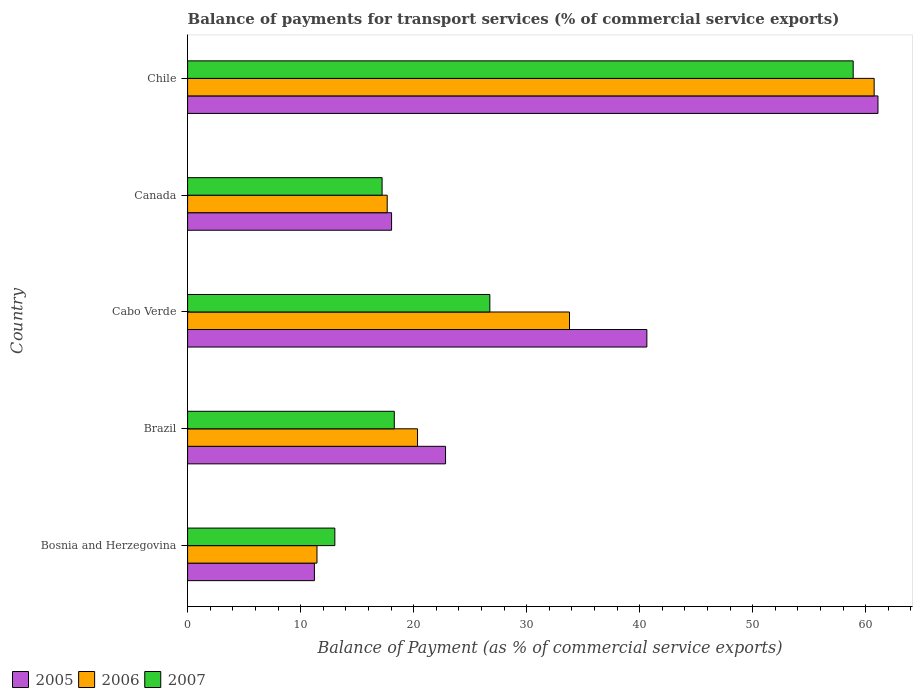Are the number of bars per tick equal to the number of legend labels?
Offer a terse response. Yes. How many bars are there on the 2nd tick from the top?
Provide a succinct answer. 3. How many bars are there on the 4th tick from the bottom?
Keep it short and to the point. 3. What is the label of the 3rd group of bars from the top?
Make the answer very short. Cabo Verde. What is the balance of payments for transport services in 2005 in Cabo Verde?
Make the answer very short. 40.64. Across all countries, what is the maximum balance of payments for transport services in 2005?
Your response must be concise. 61.09. Across all countries, what is the minimum balance of payments for transport services in 2005?
Keep it short and to the point. 11.22. In which country was the balance of payments for transport services in 2006 minimum?
Give a very brief answer. Bosnia and Herzegovina. What is the total balance of payments for transport services in 2005 in the graph?
Provide a short and direct response. 153.83. What is the difference between the balance of payments for transport services in 2007 in Bosnia and Herzegovina and that in Cabo Verde?
Provide a short and direct response. -13.72. What is the difference between the balance of payments for transport services in 2006 in Brazil and the balance of payments for transport services in 2007 in Chile?
Ensure brevity in your answer.  -38.55. What is the average balance of payments for transport services in 2006 per country?
Provide a succinct answer. 28.8. What is the difference between the balance of payments for transport services in 2006 and balance of payments for transport services in 2007 in Cabo Verde?
Offer a very short reply. 7.05. In how many countries, is the balance of payments for transport services in 2005 greater than 26 %?
Provide a succinct answer. 2. What is the ratio of the balance of payments for transport services in 2005 in Bosnia and Herzegovina to that in Chile?
Your answer should be very brief. 0.18. Is the balance of payments for transport services in 2005 in Canada less than that in Chile?
Provide a succinct answer. Yes. What is the difference between the highest and the second highest balance of payments for transport services in 2006?
Offer a very short reply. 26.96. What is the difference between the highest and the lowest balance of payments for transport services in 2005?
Your answer should be compact. 49.87. In how many countries, is the balance of payments for transport services in 2006 greater than the average balance of payments for transport services in 2006 taken over all countries?
Offer a terse response. 2. Is the sum of the balance of payments for transport services in 2006 in Bosnia and Herzegovina and Cabo Verde greater than the maximum balance of payments for transport services in 2005 across all countries?
Make the answer very short. No. What does the 2nd bar from the top in Cabo Verde represents?
Give a very brief answer. 2006. What does the 2nd bar from the bottom in Chile represents?
Make the answer very short. 2006. Is it the case that in every country, the sum of the balance of payments for transport services in 2005 and balance of payments for transport services in 2006 is greater than the balance of payments for transport services in 2007?
Offer a very short reply. Yes. How many bars are there?
Give a very brief answer. 15. How many countries are there in the graph?
Provide a succinct answer. 5. Are the values on the major ticks of X-axis written in scientific E-notation?
Your response must be concise. No. Does the graph contain any zero values?
Offer a very short reply. No. How many legend labels are there?
Offer a very short reply. 3. What is the title of the graph?
Offer a terse response. Balance of payments for transport services (% of commercial service exports). Does "1997" appear as one of the legend labels in the graph?
Ensure brevity in your answer.  No. What is the label or title of the X-axis?
Your answer should be very brief. Balance of Payment (as % of commercial service exports). What is the label or title of the Y-axis?
Your answer should be very brief. Country. What is the Balance of Payment (as % of commercial service exports) in 2005 in Bosnia and Herzegovina?
Your answer should be compact. 11.22. What is the Balance of Payment (as % of commercial service exports) in 2006 in Bosnia and Herzegovina?
Your response must be concise. 11.45. What is the Balance of Payment (as % of commercial service exports) in 2007 in Bosnia and Herzegovina?
Ensure brevity in your answer.  13.03. What is the Balance of Payment (as % of commercial service exports) of 2005 in Brazil?
Offer a terse response. 22.83. What is the Balance of Payment (as % of commercial service exports) of 2006 in Brazil?
Offer a very short reply. 20.35. What is the Balance of Payment (as % of commercial service exports) in 2007 in Brazil?
Your answer should be very brief. 18.29. What is the Balance of Payment (as % of commercial service exports) of 2005 in Cabo Verde?
Keep it short and to the point. 40.64. What is the Balance of Payment (as % of commercial service exports) in 2006 in Cabo Verde?
Your answer should be compact. 33.79. What is the Balance of Payment (as % of commercial service exports) in 2007 in Cabo Verde?
Your answer should be very brief. 26.75. What is the Balance of Payment (as % of commercial service exports) of 2005 in Canada?
Keep it short and to the point. 18.05. What is the Balance of Payment (as % of commercial service exports) in 2006 in Canada?
Your answer should be compact. 17.66. What is the Balance of Payment (as % of commercial service exports) of 2007 in Canada?
Give a very brief answer. 17.21. What is the Balance of Payment (as % of commercial service exports) in 2005 in Chile?
Your answer should be very brief. 61.09. What is the Balance of Payment (as % of commercial service exports) in 2006 in Chile?
Your response must be concise. 60.75. What is the Balance of Payment (as % of commercial service exports) in 2007 in Chile?
Make the answer very short. 58.9. Across all countries, what is the maximum Balance of Payment (as % of commercial service exports) in 2005?
Provide a short and direct response. 61.09. Across all countries, what is the maximum Balance of Payment (as % of commercial service exports) in 2006?
Provide a succinct answer. 60.75. Across all countries, what is the maximum Balance of Payment (as % of commercial service exports) of 2007?
Provide a short and direct response. 58.9. Across all countries, what is the minimum Balance of Payment (as % of commercial service exports) in 2005?
Provide a succinct answer. 11.22. Across all countries, what is the minimum Balance of Payment (as % of commercial service exports) in 2006?
Provide a succinct answer. 11.45. Across all countries, what is the minimum Balance of Payment (as % of commercial service exports) in 2007?
Provide a succinct answer. 13.03. What is the total Balance of Payment (as % of commercial service exports) of 2005 in the graph?
Keep it short and to the point. 153.83. What is the total Balance of Payment (as % of commercial service exports) of 2006 in the graph?
Provide a short and direct response. 144. What is the total Balance of Payment (as % of commercial service exports) of 2007 in the graph?
Make the answer very short. 134.17. What is the difference between the Balance of Payment (as % of commercial service exports) in 2005 in Bosnia and Herzegovina and that in Brazil?
Ensure brevity in your answer.  -11.6. What is the difference between the Balance of Payment (as % of commercial service exports) in 2006 in Bosnia and Herzegovina and that in Brazil?
Offer a terse response. -8.9. What is the difference between the Balance of Payment (as % of commercial service exports) of 2007 in Bosnia and Herzegovina and that in Brazil?
Your answer should be very brief. -5.26. What is the difference between the Balance of Payment (as % of commercial service exports) in 2005 in Bosnia and Herzegovina and that in Cabo Verde?
Your response must be concise. -29.42. What is the difference between the Balance of Payment (as % of commercial service exports) in 2006 in Bosnia and Herzegovina and that in Cabo Verde?
Keep it short and to the point. -22.35. What is the difference between the Balance of Payment (as % of commercial service exports) in 2007 in Bosnia and Herzegovina and that in Cabo Verde?
Give a very brief answer. -13.72. What is the difference between the Balance of Payment (as % of commercial service exports) of 2005 in Bosnia and Herzegovina and that in Canada?
Offer a very short reply. -6.83. What is the difference between the Balance of Payment (as % of commercial service exports) in 2006 in Bosnia and Herzegovina and that in Canada?
Keep it short and to the point. -6.21. What is the difference between the Balance of Payment (as % of commercial service exports) of 2007 in Bosnia and Herzegovina and that in Canada?
Offer a very short reply. -4.18. What is the difference between the Balance of Payment (as % of commercial service exports) in 2005 in Bosnia and Herzegovina and that in Chile?
Make the answer very short. -49.87. What is the difference between the Balance of Payment (as % of commercial service exports) of 2006 in Bosnia and Herzegovina and that in Chile?
Keep it short and to the point. -49.3. What is the difference between the Balance of Payment (as % of commercial service exports) in 2007 in Bosnia and Herzegovina and that in Chile?
Your answer should be very brief. -45.87. What is the difference between the Balance of Payment (as % of commercial service exports) of 2005 in Brazil and that in Cabo Verde?
Your response must be concise. -17.81. What is the difference between the Balance of Payment (as % of commercial service exports) in 2006 in Brazil and that in Cabo Verde?
Keep it short and to the point. -13.45. What is the difference between the Balance of Payment (as % of commercial service exports) of 2007 in Brazil and that in Cabo Verde?
Ensure brevity in your answer.  -8.45. What is the difference between the Balance of Payment (as % of commercial service exports) of 2005 in Brazil and that in Canada?
Offer a very short reply. 4.78. What is the difference between the Balance of Payment (as % of commercial service exports) of 2006 in Brazil and that in Canada?
Your answer should be compact. 2.68. What is the difference between the Balance of Payment (as % of commercial service exports) of 2007 in Brazil and that in Canada?
Your answer should be very brief. 1.08. What is the difference between the Balance of Payment (as % of commercial service exports) in 2005 in Brazil and that in Chile?
Your response must be concise. -38.26. What is the difference between the Balance of Payment (as % of commercial service exports) of 2006 in Brazil and that in Chile?
Provide a short and direct response. -40.4. What is the difference between the Balance of Payment (as % of commercial service exports) in 2007 in Brazil and that in Chile?
Ensure brevity in your answer.  -40.61. What is the difference between the Balance of Payment (as % of commercial service exports) of 2005 in Cabo Verde and that in Canada?
Your answer should be very brief. 22.59. What is the difference between the Balance of Payment (as % of commercial service exports) of 2006 in Cabo Verde and that in Canada?
Give a very brief answer. 16.13. What is the difference between the Balance of Payment (as % of commercial service exports) in 2007 in Cabo Verde and that in Canada?
Offer a terse response. 9.53. What is the difference between the Balance of Payment (as % of commercial service exports) in 2005 in Cabo Verde and that in Chile?
Provide a succinct answer. -20.45. What is the difference between the Balance of Payment (as % of commercial service exports) of 2006 in Cabo Verde and that in Chile?
Offer a very short reply. -26.96. What is the difference between the Balance of Payment (as % of commercial service exports) in 2007 in Cabo Verde and that in Chile?
Your answer should be very brief. -32.15. What is the difference between the Balance of Payment (as % of commercial service exports) in 2005 in Canada and that in Chile?
Offer a very short reply. -43.04. What is the difference between the Balance of Payment (as % of commercial service exports) of 2006 in Canada and that in Chile?
Make the answer very short. -43.09. What is the difference between the Balance of Payment (as % of commercial service exports) of 2007 in Canada and that in Chile?
Provide a short and direct response. -41.69. What is the difference between the Balance of Payment (as % of commercial service exports) in 2005 in Bosnia and Herzegovina and the Balance of Payment (as % of commercial service exports) in 2006 in Brazil?
Give a very brief answer. -9.13. What is the difference between the Balance of Payment (as % of commercial service exports) of 2005 in Bosnia and Herzegovina and the Balance of Payment (as % of commercial service exports) of 2007 in Brazil?
Keep it short and to the point. -7.07. What is the difference between the Balance of Payment (as % of commercial service exports) of 2006 in Bosnia and Herzegovina and the Balance of Payment (as % of commercial service exports) of 2007 in Brazil?
Offer a very short reply. -6.84. What is the difference between the Balance of Payment (as % of commercial service exports) in 2005 in Bosnia and Herzegovina and the Balance of Payment (as % of commercial service exports) in 2006 in Cabo Verde?
Provide a succinct answer. -22.57. What is the difference between the Balance of Payment (as % of commercial service exports) of 2005 in Bosnia and Herzegovina and the Balance of Payment (as % of commercial service exports) of 2007 in Cabo Verde?
Keep it short and to the point. -15.52. What is the difference between the Balance of Payment (as % of commercial service exports) in 2006 in Bosnia and Herzegovina and the Balance of Payment (as % of commercial service exports) in 2007 in Cabo Verde?
Your response must be concise. -15.3. What is the difference between the Balance of Payment (as % of commercial service exports) of 2005 in Bosnia and Herzegovina and the Balance of Payment (as % of commercial service exports) of 2006 in Canada?
Offer a terse response. -6.44. What is the difference between the Balance of Payment (as % of commercial service exports) of 2005 in Bosnia and Herzegovina and the Balance of Payment (as % of commercial service exports) of 2007 in Canada?
Make the answer very short. -5.99. What is the difference between the Balance of Payment (as % of commercial service exports) of 2006 in Bosnia and Herzegovina and the Balance of Payment (as % of commercial service exports) of 2007 in Canada?
Your answer should be compact. -5.76. What is the difference between the Balance of Payment (as % of commercial service exports) in 2005 in Bosnia and Herzegovina and the Balance of Payment (as % of commercial service exports) in 2006 in Chile?
Provide a short and direct response. -49.53. What is the difference between the Balance of Payment (as % of commercial service exports) in 2005 in Bosnia and Herzegovina and the Balance of Payment (as % of commercial service exports) in 2007 in Chile?
Offer a terse response. -47.68. What is the difference between the Balance of Payment (as % of commercial service exports) of 2006 in Bosnia and Herzegovina and the Balance of Payment (as % of commercial service exports) of 2007 in Chile?
Make the answer very short. -47.45. What is the difference between the Balance of Payment (as % of commercial service exports) of 2005 in Brazil and the Balance of Payment (as % of commercial service exports) of 2006 in Cabo Verde?
Offer a terse response. -10.97. What is the difference between the Balance of Payment (as % of commercial service exports) of 2005 in Brazil and the Balance of Payment (as % of commercial service exports) of 2007 in Cabo Verde?
Provide a short and direct response. -3.92. What is the difference between the Balance of Payment (as % of commercial service exports) in 2006 in Brazil and the Balance of Payment (as % of commercial service exports) in 2007 in Cabo Verde?
Provide a succinct answer. -6.4. What is the difference between the Balance of Payment (as % of commercial service exports) in 2005 in Brazil and the Balance of Payment (as % of commercial service exports) in 2006 in Canada?
Your answer should be compact. 5.16. What is the difference between the Balance of Payment (as % of commercial service exports) of 2005 in Brazil and the Balance of Payment (as % of commercial service exports) of 2007 in Canada?
Keep it short and to the point. 5.62. What is the difference between the Balance of Payment (as % of commercial service exports) of 2006 in Brazil and the Balance of Payment (as % of commercial service exports) of 2007 in Canada?
Your response must be concise. 3.14. What is the difference between the Balance of Payment (as % of commercial service exports) of 2005 in Brazil and the Balance of Payment (as % of commercial service exports) of 2006 in Chile?
Give a very brief answer. -37.93. What is the difference between the Balance of Payment (as % of commercial service exports) in 2005 in Brazil and the Balance of Payment (as % of commercial service exports) in 2007 in Chile?
Provide a succinct answer. -36.07. What is the difference between the Balance of Payment (as % of commercial service exports) in 2006 in Brazil and the Balance of Payment (as % of commercial service exports) in 2007 in Chile?
Give a very brief answer. -38.55. What is the difference between the Balance of Payment (as % of commercial service exports) in 2005 in Cabo Verde and the Balance of Payment (as % of commercial service exports) in 2006 in Canada?
Offer a very short reply. 22.98. What is the difference between the Balance of Payment (as % of commercial service exports) of 2005 in Cabo Verde and the Balance of Payment (as % of commercial service exports) of 2007 in Canada?
Offer a terse response. 23.43. What is the difference between the Balance of Payment (as % of commercial service exports) in 2006 in Cabo Verde and the Balance of Payment (as % of commercial service exports) in 2007 in Canada?
Provide a succinct answer. 16.58. What is the difference between the Balance of Payment (as % of commercial service exports) in 2005 in Cabo Verde and the Balance of Payment (as % of commercial service exports) in 2006 in Chile?
Keep it short and to the point. -20.11. What is the difference between the Balance of Payment (as % of commercial service exports) in 2005 in Cabo Verde and the Balance of Payment (as % of commercial service exports) in 2007 in Chile?
Ensure brevity in your answer.  -18.26. What is the difference between the Balance of Payment (as % of commercial service exports) of 2006 in Cabo Verde and the Balance of Payment (as % of commercial service exports) of 2007 in Chile?
Provide a short and direct response. -25.1. What is the difference between the Balance of Payment (as % of commercial service exports) in 2005 in Canada and the Balance of Payment (as % of commercial service exports) in 2006 in Chile?
Your answer should be compact. -42.7. What is the difference between the Balance of Payment (as % of commercial service exports) of 2005 in Canada and the Balance of Payment (as % of commercial service exports) of 2007 in Chile?
Your answer should be compact. -40.85. What is the difference between the Balance of Payment (as % of commercial service exports) of 2006 in Canada and the Balance of Payment (as % of commercial service exports) of 2007 in Chile?
Give a very brief answer. -41.23. What is the average Balance of Payment (as % of commercial service exports) in 2005 per country?
Your answer should be very brief. 30.77. What is the average Balance of Payment (as % of commercial service exports) of 2006 per country?
Keep it short and to the point. 28.8. What is the average Balance of Payment (as % of commercial service exports) in 2007 per country?
Keep it short and to the point. 26.83. What is the difference between the Balance of Payment (as % of commercial service exports) in 2005 and Balance of Payment (as % of commercial service exports) in 2006 in Bosnia and Herzegovina?
Your response must be concise. -0.23. What is the difference between the Balance of Payment (as % of commercial service exports) of 2005 and Balance of Payment (as % of commercial service exports) of 2007 in Bosnia and Herzegovina?
Your answer should be very brief. -1.81. What is the difference between the Balance of Payment (as % of commercial service exports) in 2006 and Balance of Payment (as % of commercial service exports) in 2007 in Bosnia and Herzegovina?
Ensure brevity in your answer.  -1.58. What is the difference between the Balance of Payment (as % of commercial service exports) of 2005 and Balance of Payment (as % of commercial service exports) of 2006 in Brazil?
Keep it short and to the point. 2.48. What is the difference between the Balance of Payment (as % of commercial service exports) in 2005 and Balance of Payment (as % of commercial service exports) in 2007 in Brazil?
Make the answer very short. 4.54. What is the difference between the Balance of Payment (as % of commercial service exports) of 2006 and Balance of Payment (as % of commercial service exports) of 2007 in Brazil?
Your answer should be very brief. 2.06. What is the difference between the Balance of Payment (as % of commercial service exports) of 2005 and Balance of Payment (as % of commercial service exports) of 2006 in Cabo Verde?
Your answer should be very brief. 6.85. What is the difference between the Balance of Payment (as % of commercial service exports) of 2005 and Balance of Payment (as % of commercial service exports) of 2007 in Cabo Verde?
Give a very brief answer. 13.89. What is the difference between the Balance of Payment (as % of commercial service exports) in 2006 and Balance of Payment (as % of commercial service exports) in 2007 in Cabo Verde?
Offer a very short reply. 7.05. What is the difference between the Balance of Payment (as % of commercial service exports) of 2005 and Balance of Payment (as % of commercial service exports) of 2006 in Canada?
Your response must be concise. 0.39. What is the difference between the Balance of Payment (as % of commercial service exports) of 2005 and Balance of Payment (as % of commercial service exports) of 2007 in Canada?
Make the answer very short. 0.84. What is the difference between the Balance of Payment (as % of commercial service exports) of 2006 and Balance of Payment (as % of commercial service exports) of 2007 in Canada?
Your response must be concise. 0.45. What is the difference between the Balance of Payment (as % of commercial service exports) in 2005 and Balance of Payment (as % of commercial service exports) in 2006 in Chile?
Offer a very short reply. 0.34. What is the difference between the Balance of Payment (as % of commercial service exports) in 2005 and Balance of Payment (as % of commercial service exports) in 2007 in Chile?
Give a very brief answer. 2.19. What is the difference between the Balance of Payment (as % of commercial service exports) in 2006 and Balance of Payment (as % of commercial service exports) in 2007 in Chile?
Your response must be concise. 1.85. What is the ratio of the Balance of Payment (as % of commercial service exports) in 2005 in Bosnia and Herzegovina to that in Brazil?
Keep it short and to the point. 0.49. What is the ratio of the Balance of Payment (as % of commercial service exports) in 2006 in Bosnia and Herzegovina to that in Brazil?
Offer a terse response. 0.56. What is the ratio of the Balance of Payment (as % of commercial service exports) in 2007 in Bosnia and Herzegovina to that in Brazil?
Your answer should be compact. 0.71. What is the ratio of the Balance of Payment (as % of commercial service exports) of 2005 in Bosnia and Herzegovina to that in Cabo Verde?
Provide a short and direct response. 0.28. What is the ratio of the Balance of Payment (as % of commercial service exports) in 2006 in Bosnia and Herzegovina to that in Cabo Verde?
Keep it short and to the point. 0.34. What is the ratio of the Balance of Payment (as % of commercial service exports) of 2007 in Bosnia and Herzegovina to that in Cabo Verde?
Offer a terse response. 0.49. What is the ratio of the Balance of Payment (as % of commercial service exports) in 2005 in Bosnia and Herzegovina to that in Canada?
Ensure brevity in your answer.  0.62. What is the ratio of the Balance of Payment (as % of commercial service exports) in 2006 in Bosnia and Herzegovina to that in Canada?
Offer a terse response. 0.65. What is the ratio of the Balance of Payment (as % of commercial service exports) in 2007 in Bosnia and Herzegovina to that in Canada?
Provide a short and direct response. 0.76. What is the ratio of the Balance of Payment (as % of commercial service exports) of 2005 in Bosnia and Herzegovina to that in Chile?
Your answer should be very brief. 0.18. What is the ratio of the Balance of Payment (as % of commercial service exports) in 2006 in Bosnia and Herzegovina to that in Chile?
Your answer should be compact. 0.19. What is the ratio of the Balance of Payment (as % of commercial service exports) of 2007 in Bosnia and Herzegovina to that in Chile?
Make the answer very short. 0.22. What is the ratio of the Balance of Payment (as % of commercial service exports) of 2005 in Brazil to that in Cabo Verde?
Give a very brief answer. 0.56. What is the ratio of the Balance of Payment (as % of commercial service exports) of 2006 in Brazil to that in Cabo Verde?
Your answer should be compact. 0.6. What is the ratio of the Balance of Payment (as % of commercial service exports) of 2007 in Brazil to that in Cabo Verde?
Your answer should be very brief. 0.68. What is the ratio of the Balance of Payment (as % of commercial service exports) in 2005 in Brazil to that in Canada?
Keep it short and to the point. 1.26. What is the ratio of the Balance of Payment (as % of commercial service exports) in 2006 in Brazil to that in Canada?
Provide a succinct answer. 1.15. What is the ratio of the Balance of Payment (as % of commercial service exports) in 2007 in Brazil to that in Canada?
Keep it short and to the point. 1.06. What is the ratio of the Balance of Payment (as % of commercial service exports) of 2005 in Brazil to that in Chile?
Offer a very short reply. 0.37. What is the ratio of the Balance of Payment (as % of commercial service exports) of 2006 in Brazil to that in Chile?
Keep it short and to the point. 0.33. What is the ratio of the Balance of Payment (as % of commercial service exports) of 2007 in Brazil to that in Chile?
Offer a very short reply. 0.31. What is the ratio of the Balance of Payment (as % of commercial service exports) of 2005 in Cabo Verde to that in Canada?
Your answer should be very brief. 2.25. What is the ratio of the Balance of Payment (as % of commercial service exports) in 2006 in Cabo Verde to that in Canada?
Provide a succinct answer. 1.91. What is the ratio of the Balance of Payment (as % of commercial service exports) in 2007 in Cabo Verde to that in Canada?
Keep it short and to the point. 1.55. What is the ratio of the Balance of Payment (as % of commercial service exports) in 2005 in Cabo Verde to that in Chile?
Ensure brevity in your answer.  0.67. What is the ratio of the Balance of Payment (as % of commercial service exports) of 2006 in Cabo Verde to that in Chile?
Offer a very short reply. 0.56. What is the ratio of the Balance of Payment (as % of commercial service exports) in 2007 in Cabo Verde to that in Chile?
Provide a short and direct response. 0.45. What is the ratio of the Balance of Payment (as % of commercial service exports) in 2005 in Canada to that in Chile?
Offer a terse response. 0.3. What is the ratio of the Balance of Payment (as % of commercial service exports) in 2006 in Canada to that in Chile?
Ensure brevity in your answer.  0.29. What is the ratio of the Balance of Payment (as % of commercial service exports) of 2007 in Canada to that in Chile?
Make the answer very short. 0.29. What is the difference between the highest and the second highest Balance of Payment (as % of commercial service exports) in 2005?
Offer a terse response. 20.45. What is the difference between the highest and the second highest Balance of Payment (as % of commercial service exports) of 2006?
Provide a succinct answer. 26.96. What is the difference between the highest and the second highest Balance of Payment (as % of commercial service exports) of 2007?
Make the answer very short. 32.15. What is the difference between the highest and the lowest Balance of Payment (as % of commercial service exports) in 2005?
Offer a very short reply. 49.87. What is the difference between the highest and the lowest Balance of Payment (as % of commercial service exports) of 2006?
Your response must be concise. 49.3. What is the difference between the highest and the lowest Balance of Payment (as % of commercial service exports) of 2007?
Give a very brief answer. 45.87. 